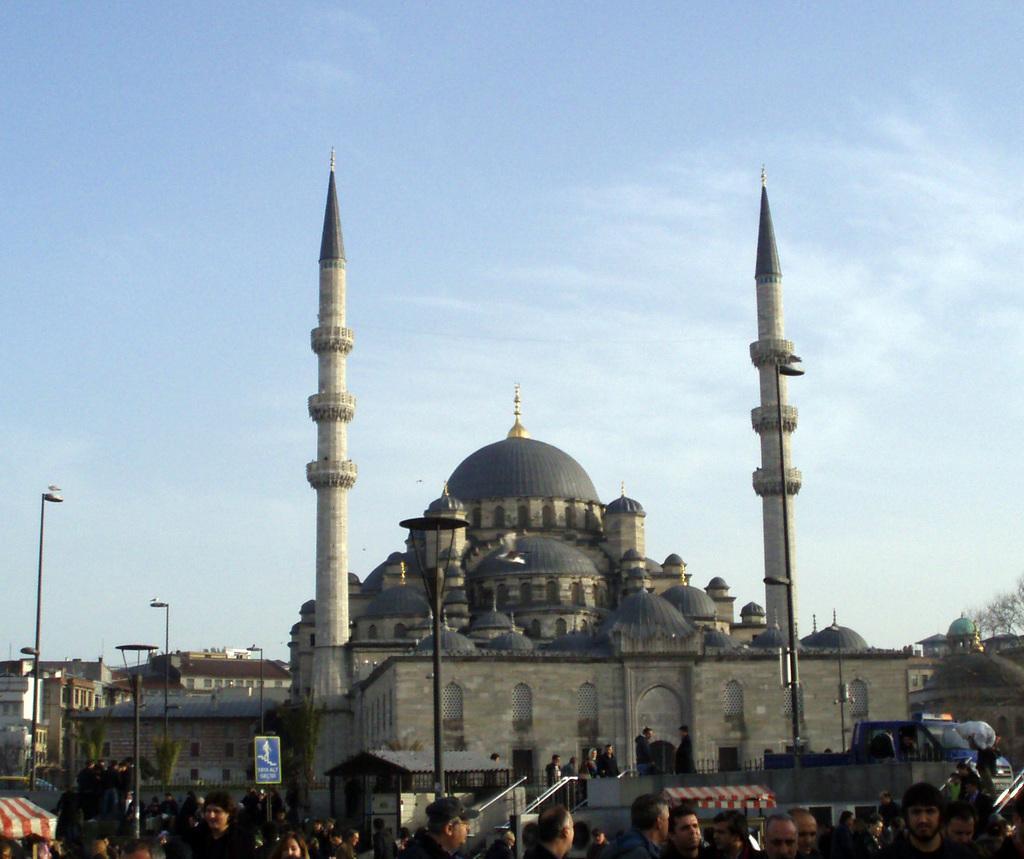In one or two sentences, can you explain what this image depicts? At the bottom of the picture, we see people are standing. In the middle of the picture, we see a tomb. Beside that, we see a staircase and the stair railing. Beside that, people are standing. On the left side, we see a tent in white and red color. Beside that, we see the street lights and poles. There are buildings in the background. On the right side, we see a vehicle in blue color is parked on the road. Behind that, we see the trees. At the top, we see the sky. 